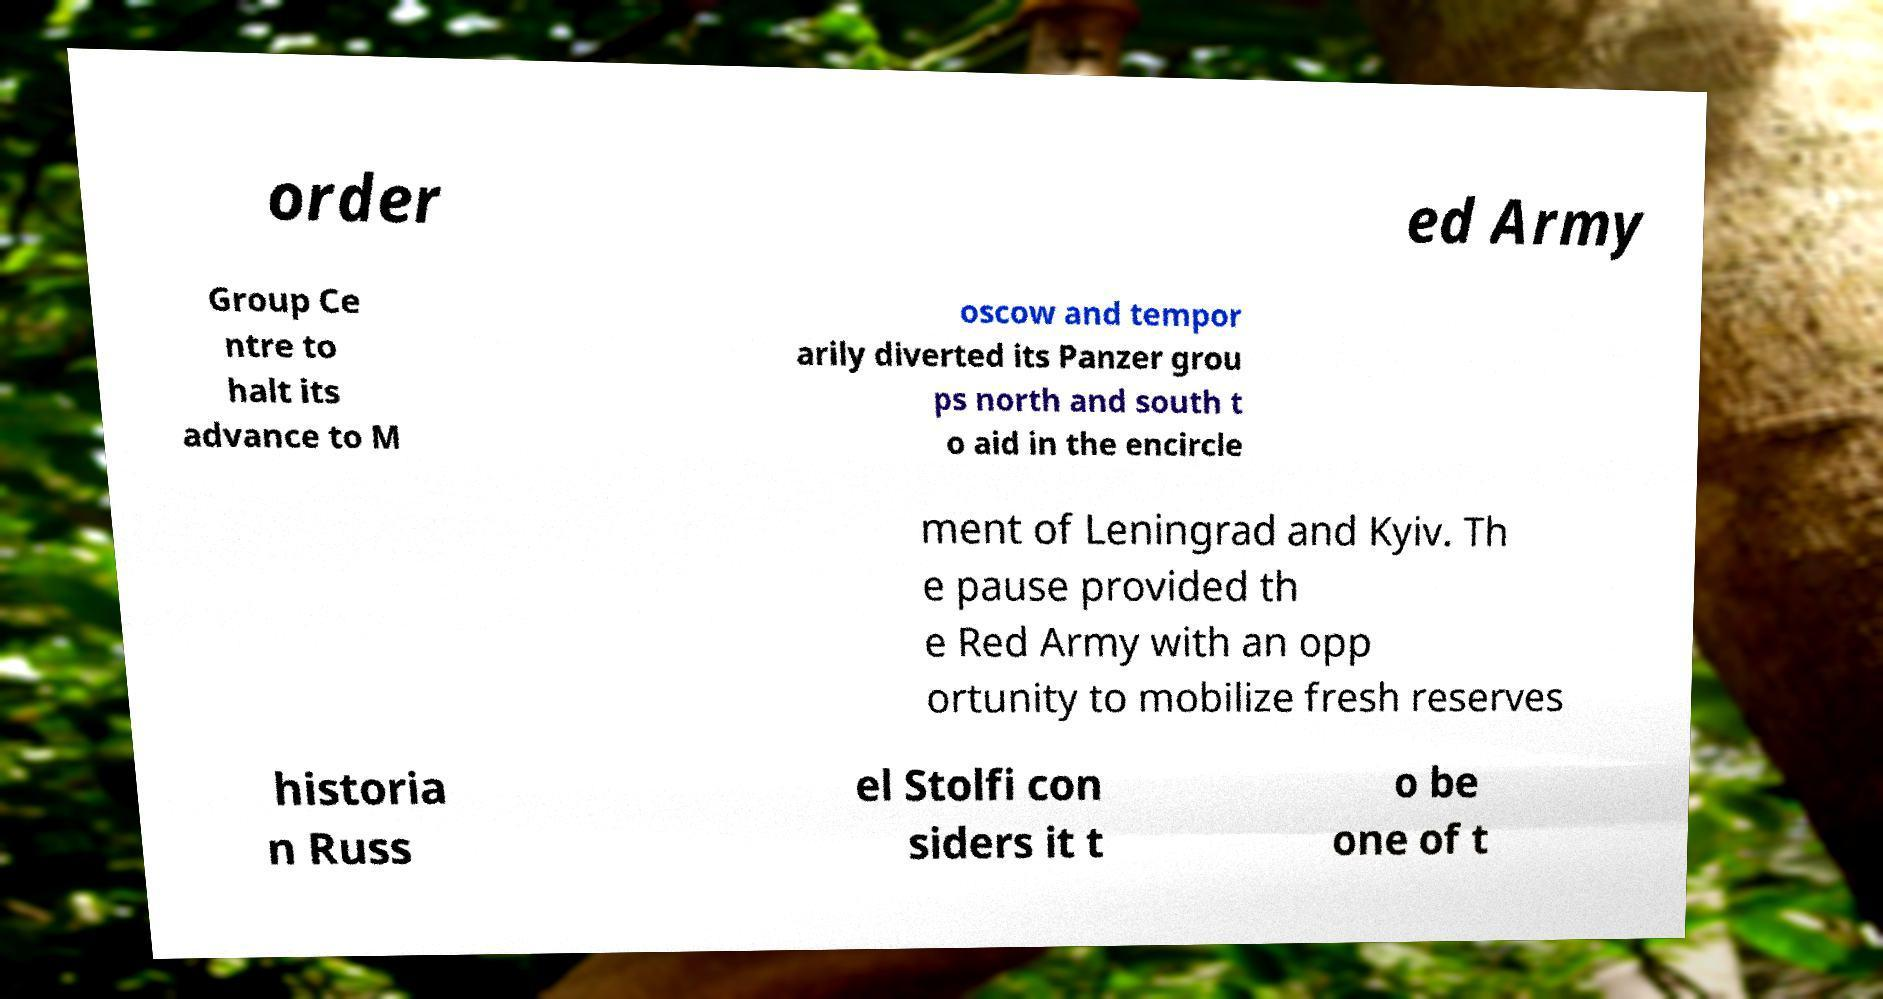There's text embedded in this image that I need extracted. Can you transcribe it verbatim? order ed Army Group Ce ntre to halt its advance to M oscow and tempor arily diverted its Panzer grou ps north and south t o aid in the encircle ment of Leningrad and Kyiv. Th e pause provided th e Red Army with an opp ortunity to mobilize fresh reserves historia n Russ el Stolfi con siders it t o be one of t 